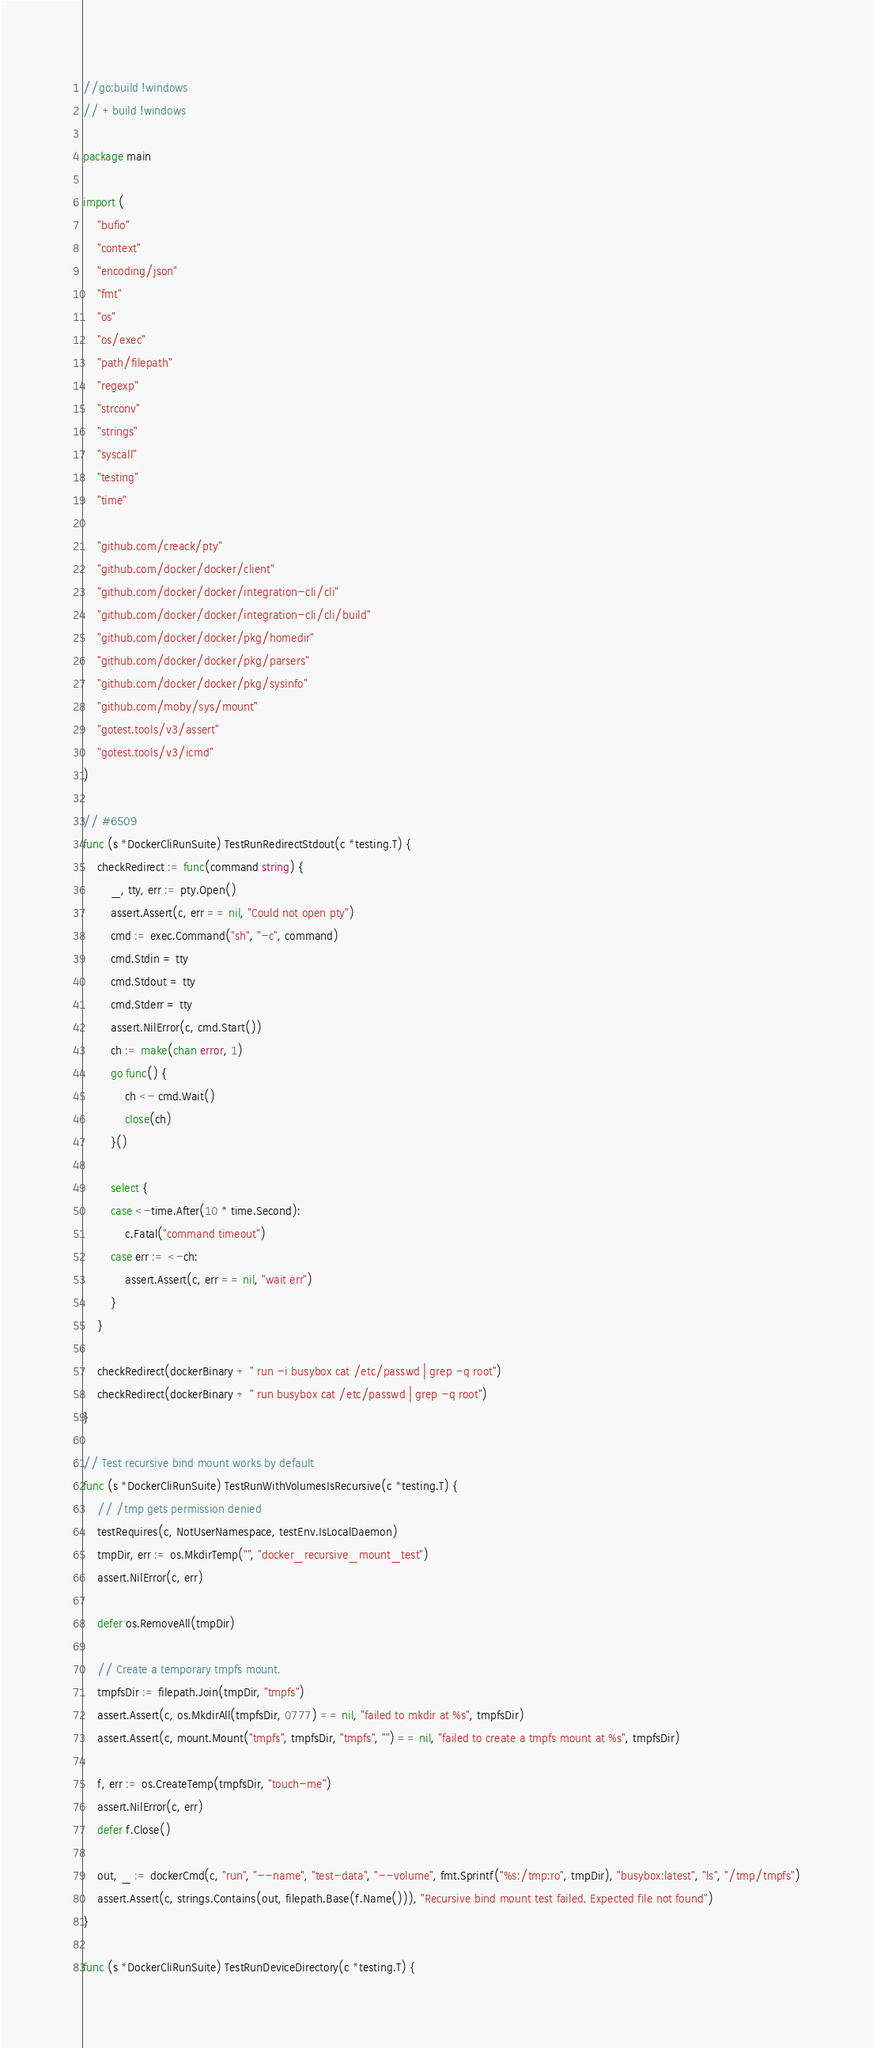Convert code to text. <code><loc_0><loc_0><loc_500><loc_500><_Go_>//go:build !windows
// +build !windows

package main

import (
	"bufio"
	"context"
	"encoding/json"
	"fmt"
	"os"
	"os/exec"
	"path/filepath"
	"regexp"
	"strconv"
	"strings"
	"syscall"
	"testing"
	"time"

	"github.com/creack/pty"
	"github.com/docker/docker/client"
	"github.com/docker/docker/integration-cli/cli"
	"github.com/docker/docker/integration-cli/cli/build"
	"github.com/docker/docker/pkg/homedir"
	"github.com/docker/docker/pkg/parsers"
	"github.com/docker/docker/pkg/sysinfo"
	"github.com/moby/sys/mount"
	"gotest.tools/v3/assert"
	"gotest.tools/v3/icmd"
)

// #6509
func (s *DockerCliRunSuite) TestRunRedirectStdout(c *testing.T) {
	checkRedirect := func(command string) {
		_, tty, err := pty.Open()
		assert.Assert(c, err == nil, "Could not open pty")
		cmd := exec.Command("sh", "-c", command)
		cmd.Stdin = tty
		cmd.Stdout = tty
		cmd.Stderr = tty
		assert.NilError(c, cmd.Start())
		ch := make(chan error, 1)
		go func() {
			ch <- cmd.Wait()
			close(ch)
		}()

		select {
		case <-time.After(10 * time.Second):
			c.Fatal("command timeout")
		case err := <-ch:
			assert.Assert(c, err == nil, "wait err")
		}
	}

	checkRedirect(dockerBinary + " run -i busybox cat /etc/passwd | grep -q root")
	checkRedirect(dockerBinary + " run busybox cat /etc/passwd | grep -q root")
}

// Test recursive bind mount works by default
func (s *DockerCliRunSuite) TestRunWithVolumesIsRecursive(c *testing.T) {
	// /tmp gets permission denied
	testRequires(c, NotUserNamespace, testEnv.IsLocalDaemon)
	tmpDir, err := os.MkdirTemp("", "docker_recursive_mount_test")
	assert.NilError(c, err)

	defer os.RemoveAll(tmpDir)

	// Create a temporary tmpfs mount.
	tmpfsDir := filepath.Join(tmpDir, "tmpfs")
	assert.Assert(c, os.MkdirAll(tmpfsDir, 0777) == nil, "failed to mkdir at %s", tmpfsDir)
	assert.Assert(c, mount.Mount("tmpfs", tmpfsDir, "tmpfs", "") == nil, "failed to create a tmpfs mount at %s", tmpfsDir)

	f, err := os.CreateTemp(tmpfsDir, "touch-me")
	assert.NilError(c, err)
	defer f.Close()

	out, _ := dockerCmd(c, "run", "--name", "test-data", "--volume", fmt.Sprintf("%s:/tmp:ro", tmpDir), "busybox:latest", "ls", "/tmp/tmpfs")
	assert.Assert(c, strings.Contains(out, filepath.Base(f.Name())), "Recursive bind mount test failed. Expected file not found")
}

func (s *DockerCliRunSuite) TestRunDeviceDirectory(c *testing.T) {</code> 